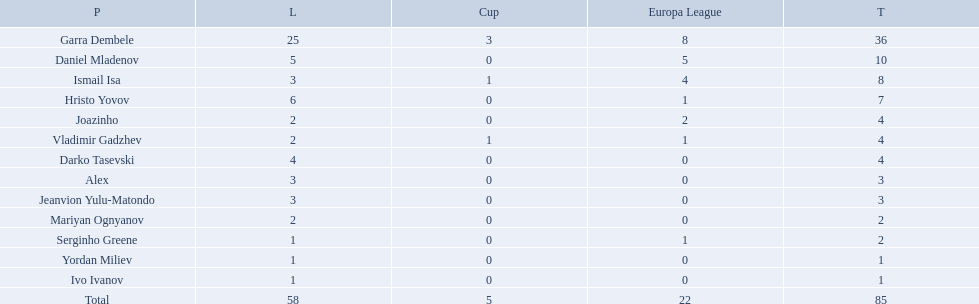What league is 2? 2, 2, 2. Which cup is less than 1? 0, 0. Which total is 2? 2. Who is the player? Mariyan Ognyanov. 